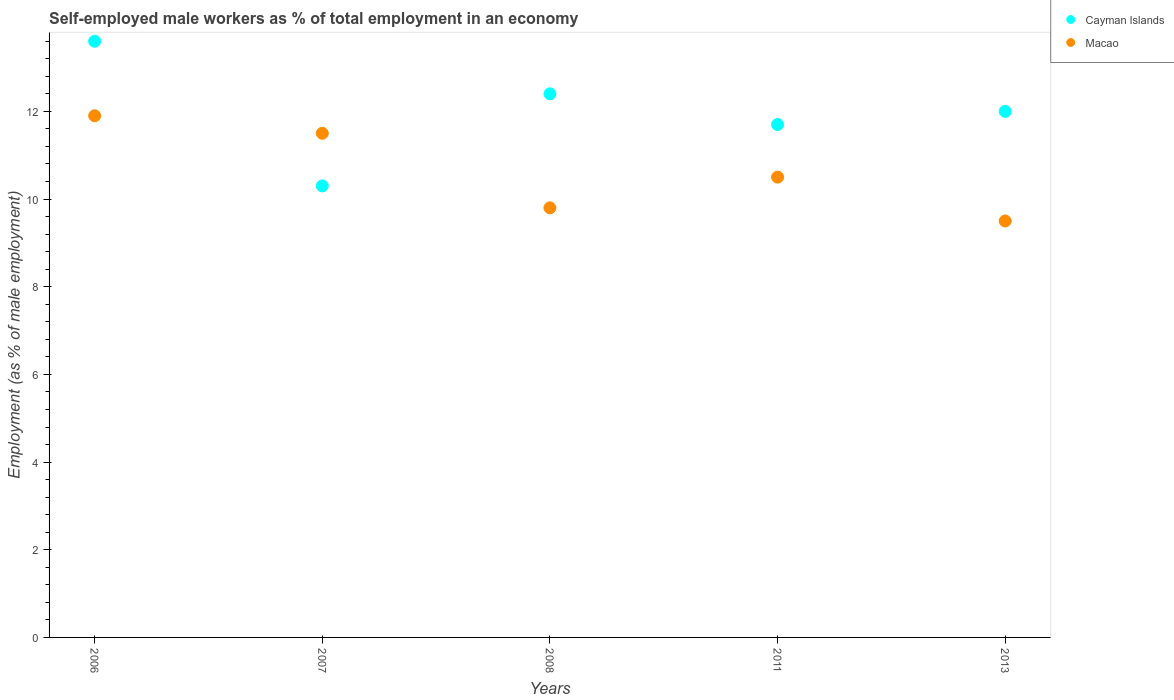Is the number of dotlines equal to the number of legend labels?
Keep it short and to the point. Yes. What is the percentage of self-employed male workers in Macao in 2013?
Provide a succinct answer. 9.5. Across all years, what is the maximum percentage of self-employed male workers in Cayman Islands?
Keep it short and to the point. 13.6. Across all years, what is the minimum percentage of self-employed male workers in Macao?
Your answer should be compact. 9.5. In which year was the percentage of self-employed male workers in Macao minimum?
Ensure brevity in your answer.  2013. What is the total percentage of self-employed male workers in Cayman Islands in the graph?
Offer a terse response. 60. What is the difference between the percentage of self-employed male workers in Cayman Islands in 2006 and that in 2007?
Provide a short and direct response. 3.3. What is the difference between the percentage of self-employed male workers in Macao in 2006 and the percentage of self-employed male workers in Cayman Islands in 2013?
Provide a short and direct response. -0.1. What is the average percentage of self-employed male workers in Macao per year?
Your response must be concise. 10.64. In the year 2007, what is the difference between the percentage of self-employed male workers in Macao and percentage of self-employed male workers in Cayman Islands?
Give a very brief answer. 1.2. In how many years, is the percentage of self-employed male workers in Cayman Islands greater than 10.4 %?
Make the answer very short. 4. What is the ratio of the percentage of self-employed male workers in Macao in 2008 to that in 2013?
Provide a short and direct response. 1.03. Is the difference between the percentage of self-employed male workers in Macao in 2006 and 2013 greater than the difference between the percentage of self-employed male workers in Cayman Islands in 2006 and 2013?
Make the answer very short. Yes. What is the difference between the highest and the second highest percentage of self-employed male workers in Cayman Islands?
Your answer should be very brief. 1.2. What is the difference between the highest and the lowest percentage of self-employed male workers in Macao?
Offer a terse response. 2.4. In how many years, is the percentage of self-employed male workers in Cayman Islands greater than the average percentage of self-employed male workers in Cayman Islands taken over all years?
Keep it short and to the point. 2. Does the percentage of self-employed male workers in Cayman Islands monotonically increase over the years?
Your answer should be very brief. No. How many dotlines are there?
Offer a very short reply. 2. Are the values on the major ticks of Y-axis written in scientific E-notation?
Keep it short and to the point. No. Does the graph contain any zero values?
Offer a terse response. No. Does the graph contain grids?
Offer a terse response. No. How many legend labels are there?
Your response must be concise. 2. How are the legend labels stacked?
Provide a short and direct response. Vertical. What is the title of the graph?
Offer a terse response. Self-employed male workers as % of total employment in an economy. Does "Venezuela" appear as one of the legend labels in the graph?
Your answer should be compact. No. What is the label or title of the Y-axis?
Provide a short and direct response. Employment (as % of male employment). What is the Employment (as % of male employment) in Cayman Islands in 2006?
Keep it short and to the point. 13.6. What is the Employment (as % of male employment) of Macao in 2006?
Ensure brevity in your answer.  11.9. What is the Employment (as % of male employment) of Cayman Islands in 2007?
Your response must be concise. 10.3. What is the Employment (as % of male employment) in Cayman Islands in 2008?
Provide a succinct answer. 12.4. What is the Employment (as % of male employment) in Macao in 2008?
Give a very brief answer. 9.8. What is the Employment (as % of male employment) of Cayman Islands in 2011?
Provide a succinct answer. 11.7. Across all years, what is the maximum Employment (as % of male employment) of Cayman Islands?
Offer a very short reply. 13.6. Across all years, what is the maximum Employment (as % of male employment) in Macao?
Offer a very short reply. 11.9. Across all years, what is the minimum Employment (as % of male employment) of Cayman Islands?
Offer a very short reply. 10.3. What is the total Employment (as % of male employment) of Cayman Islands in the graph?
Make the answer very short. 60. What is the total Employment (as % of male employment) in Macao in the graph?
Provide a short and direct response. 53.2. What is the difference between the Employment (as % of male employment) of Macao in 2006 and that in 2007?
Keep it short and to the point. 0.4. What is the difference between the Employment (as % of male employment) of Cayman Islands in 2006 and that in 2011?
Offer a terse response. 1.9. What is the difference between the Employment (as % of male employment) of Macao in 2006 and that in 2011?
Offer a very short reply. 1.4. What is the difference between the Employment (as % of male employment) of Cayman Islands in 2006 and that in 2013?
Offer a very short reply. 1.6. What is the difference between the Employment (as % of male employment) of Macao in 2006 and that in 2013?
Provide a short and direct response. 2.4. What is the difference between the Employment (as % of male employment) in Cayman Islands in 2007 and that in 2008?
Keep it short and to the point. -2.1. What is the difference between the Employment (as % of male employment) in Macao in 2007 and that in 2011?
Provide a short and direct response. 1. What is the difference between the Employment (as % of male employment) of Macao in 2007 and that in 2013?
Give a very brief answer. 2. What is the difference between the Employment (as % of male employment) in Macao in 2008 and that in 2011?
Your answer should be compact. -0.7. What is the difference between the Employment (as % of male employment) of Cayman Islands in 2008 and that in 2013?
Give a very brief answer. 0.4. What is the difference between the Employment (as % of male employment) of Cayman Islands in 2006 and the Employment (as % of male employment) of Macao in 2008?
Your response must be concise. 3.8. What is the difference between the Employment (as % of male employment) of Cayman Islands in 2006 and the Employment (as % of male employment) of Macao in 2011?
Keep it short and to the point. 3.1. What is the difference between the Employment (as % of male employment) of Cayman Islands in 2007 and the Employment (as % of male employment) of Macao in 2008?
Your response must be concise. 0.5. What is the difference between the Employment (as % of male employment) in Cayman Islands in 2007 and the Employment (as % of male employment) in Macao in 2011?
Your response must be concise. -0.2. What is the difference between the Employment (as % of male employment) of Cayman Islands in 2008 and the Employment (as % of male employment) of Macao in 2011?
Ensure brevity in your answer.  1.9. What is the difference between the Employment (as % of male employment) in Cayman Islands in 2011 and the Employment (as % of male employment) in Macao in 2013?
Offer a very short reply. 2.2. What is the average Employment (as % of male employment) in Macao per year?
Offer a very short reply. 10.64. In the year 2006, what is the difference between the Employment (as % of male employment) of Cayman Islands and Employment (as % of male employment) of Macao?
Keep it short and to the point. 1.7. In the year 2008, what is the difference between the Employment (as % of male employment) in Cayman Islands and Employment (as % of male employment) in Macao?
Provide a succinct answer. 2.6. In the year 2013, what is the difference between the Employment (as % of male employment) of Cayman Islands and Employment (as % of male employment) of Macao?
Offer a very short reply. 2.5. What is the ratio of the Employment (as % of male employment) of Cayman Islands in 2006 to that in 2007?
Provide a short and direct response. 1.32. What is the ratio of the Employment (as % of male employment) in Macao in 2006 to that in 2007?
Provide a short and direct response. 1.03. What is the ratio of the Employment (as % of male employment) in Cayman Islands in 2006 to that in 2008?
Keep it short and to the point. 1.1. What is the ratio of the Employment (as % of male employment) in Macao in 2006 to that in 2008?
Your response must be concise. 1.21. What is the ratio of the Employment (as % of male employment) in Cayman Islands in 2006 to that in 2011?
Your answer should be very brief. 1.16. What is the ratio of the Employment (as % of male employment) in Macao in 2006 to that in 2011?
Ensure brevity in your answer.  1.13. What is the ratio of the Employment (as % of male employment) in Cayman Islands in 2006 to that in 2013?
Provide a short and direct response. 1.13. What is the ratio of the Employment (as % of male employment) in Macao in 2006 to that in 2013?
Your response must be concise. 1.25. What is the ratio of the Employment (as % of male employment) in Cayman Islands in 2007 to that in 2008?
Offer a very short reply. 0.83. What is the ratio of the Employment (as % of male employment) in Macao in 2007 to that in 2008?
Keep it short and to the point. 1.17. What is the ratio of the Employment (as % of male employment) in Cayman Islands in 2007 to that in 2011?
Your answer should be very brief. 0.88. What is the ratio of the Employment (as % of male employment) in Macao in 2007 to that in 2011?
Provide a short and direct response. 1.1. What is the ratio of the Employment (as % of male employment) of Cayman Islands in 2007 to that in 2013?
Your answer should be very brief. 0.86. What is the ratio of the Employment (as % of male employment) in Macao in 2007 to that in 2013?
Ensure brevity in your answer.  1.21. What is the ratio of the Employment (as % of male employment) of Cayman Islands in 2008 to that in 2011?
Give a very brief answer. 1.06. What is the ratio of the Employment (as % of male employment) of Macao in 2008 to that in 2013?
Ensure brevity in your answer.  1.03. What is the ratio of the Employment (as % of male employment) of Macao in 2011 to that in 2013?
Provide a succinct answer. 1.11. What is the difference between the highest and the second highest Employment (as % of male employment) in Cayman Islands?
Keep it short and to the point. 1.2. What is the difference between the highest and the lowest Employment (as % of male employment) of Cayman Islands?
Your answer should be compact. 3.3. What is the difference between the highest and the lowest Employment (as % of male employment) in Macao?
Your response must be concise. 2.4. 